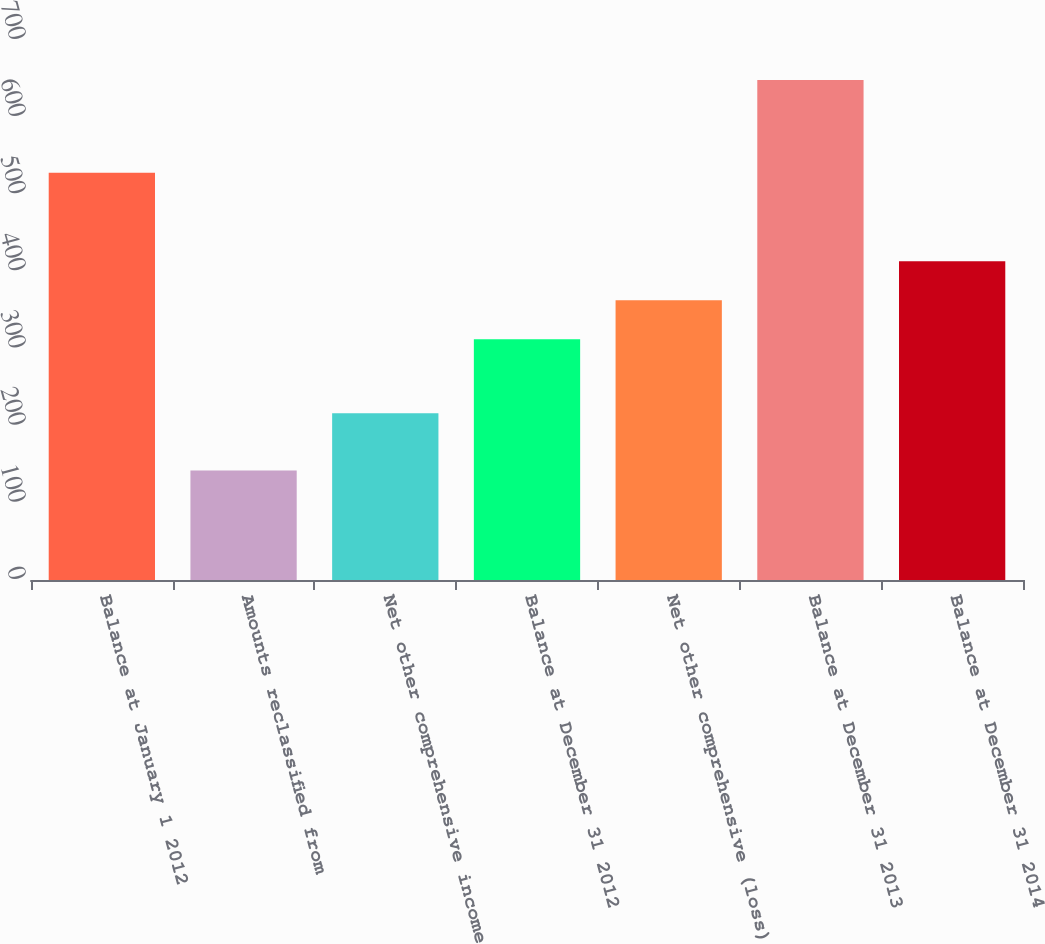<chart> <loc_0><loc_0><loc_500><loc_500><bar_chart><fcel>Balance at January 1 2012<fcel>Amounts reclassified from<fcel>Net other comprehensive income<fcel>Balance at December 31 2012<fcel>Net other comprehensive (loss)<fcel>Balance at December 31 2013<fcel>Balance at December 31 2014<nl><fcel>528<fcel>142<fcel>216<fcel>312<fcel>362.6<fcel>648<fcel>413.2<nl></chart> 